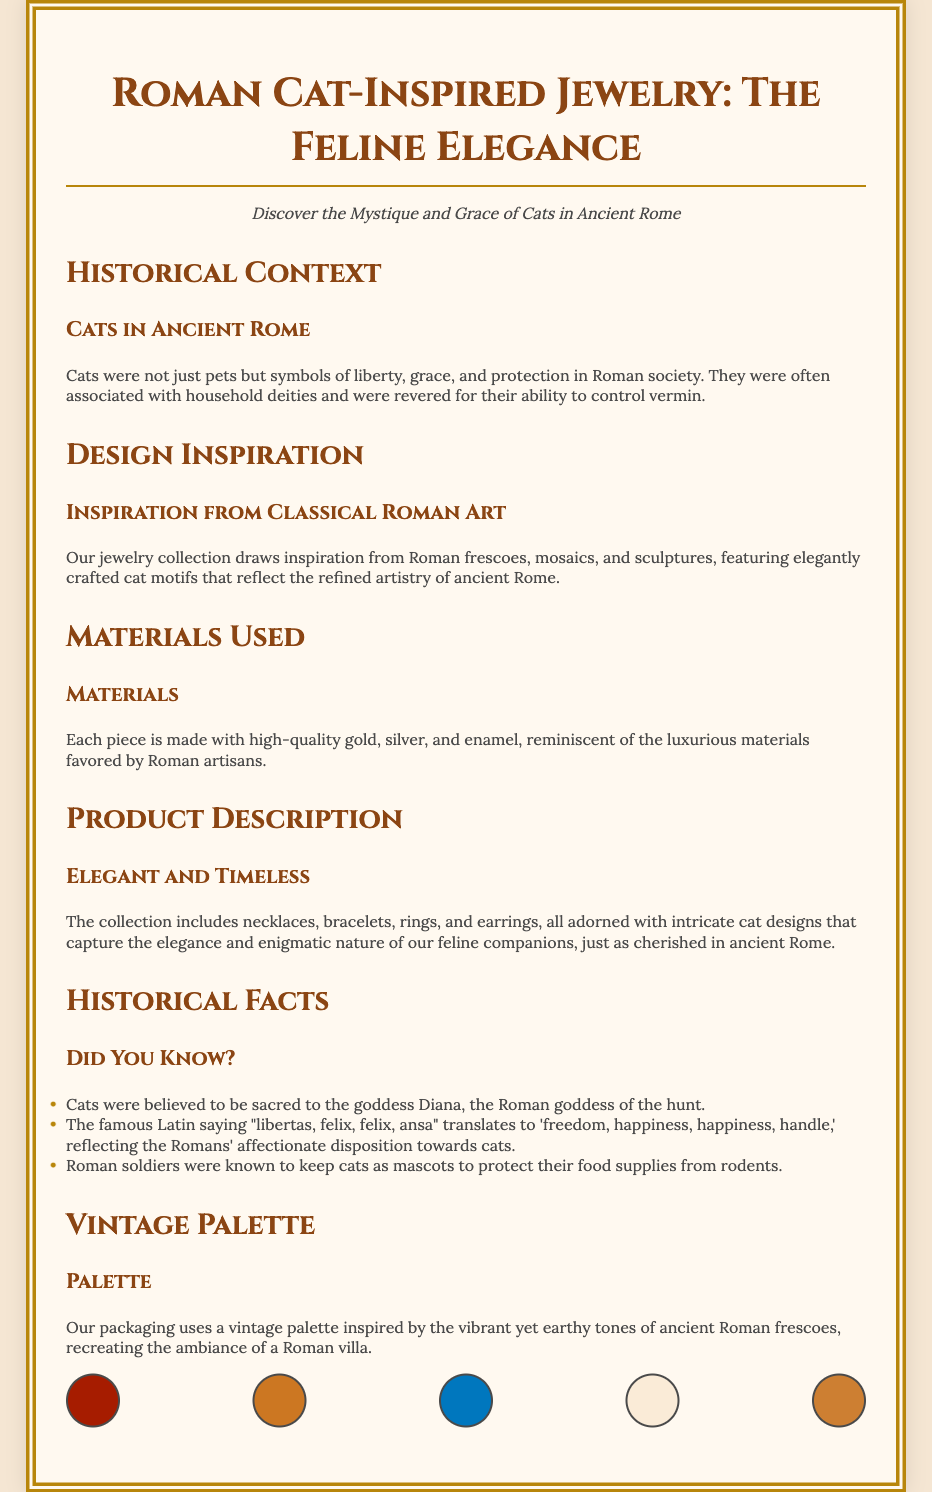What is the title of the collection? The title of the collection is stated at the top of the document.
Answer: Roman Cat-Inspired Jewelry: The Feline Elegance What does the subtitle suggest about the theme? The subtitle relates to the mystique and grace associated with cats in ancient Rome.
Answer: Discover the Mystique and Grace of Cats in Ancient Rome Which goddess were cats believed to be sacred to? This information is found in the section on Historical Facts.
Answer: Diana What materials are mentioned in the packaging for the jewelry? The materials used are listed under the Materials Used section.
Answer: Gold, silver, and enamel How many historical facts are listed in the document? The number of facts can be counted in the Historical Facts section.
Answer: Three What kind of motifs do the jewelry pieces feature? The type of motifs is explained in the Design Inspiration section.
Answer: Cat motifs What is the primary color theme of the packaging? The color theme is discussed in the Vintage Palette section.
Answer: Vintage palette What type of products are included in the collection? The products are detailed in the Product Description section.
Answer: Necklaces, bracelets, rings, and earrings Which historical saying is mentioned in the document? This saying is found in the Historical Facts section, illustrating Roman attitudes toward cats.
Answer: "libertas, felix, felix, ansa" 